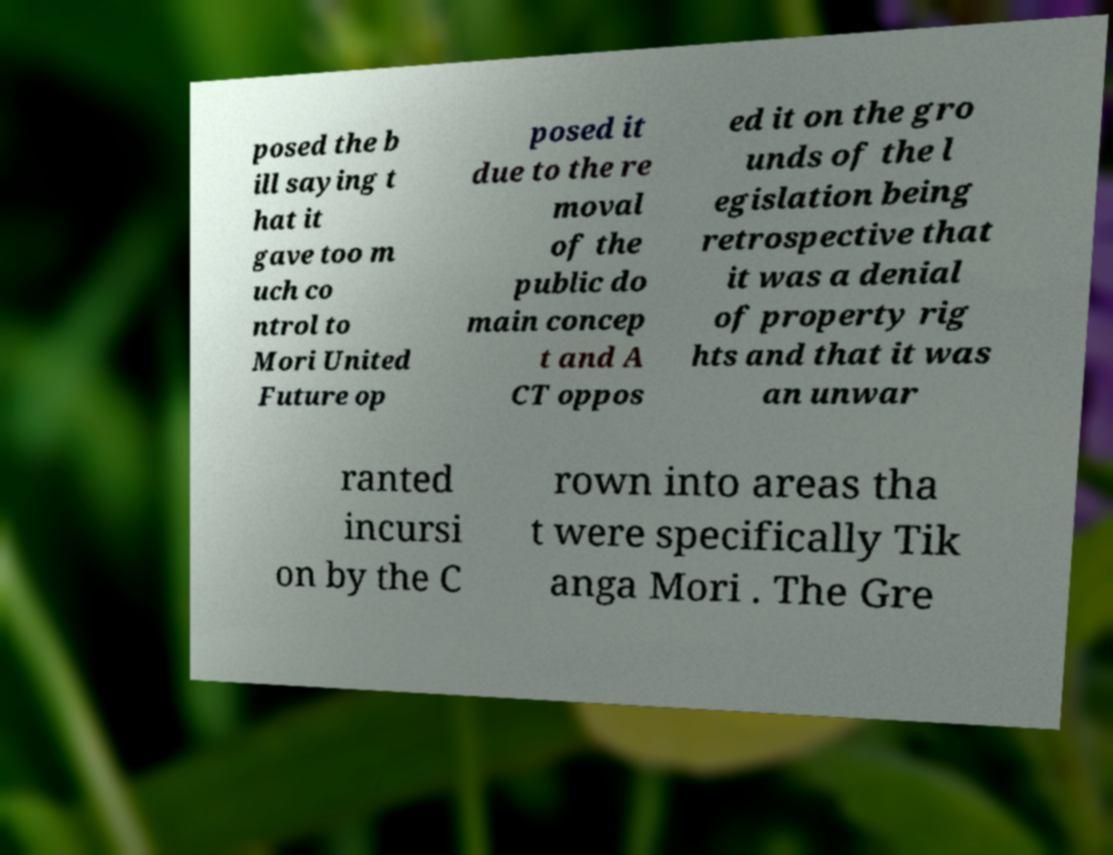What messages or text are displayed in this image? I need them in a readable, typed format. posed the b ill saying t hat it gave too m uch co ntrol to Mori United Future op posed it due to the re moval of the public do main concep t and A CT oppos ed it on the gro unds of the l egislation being retrospective that it was a denial of property rig hts and that it was an unwar ranted incursi on by the C rown into areas tha t were specifically Tik anga Mori . The Gre 